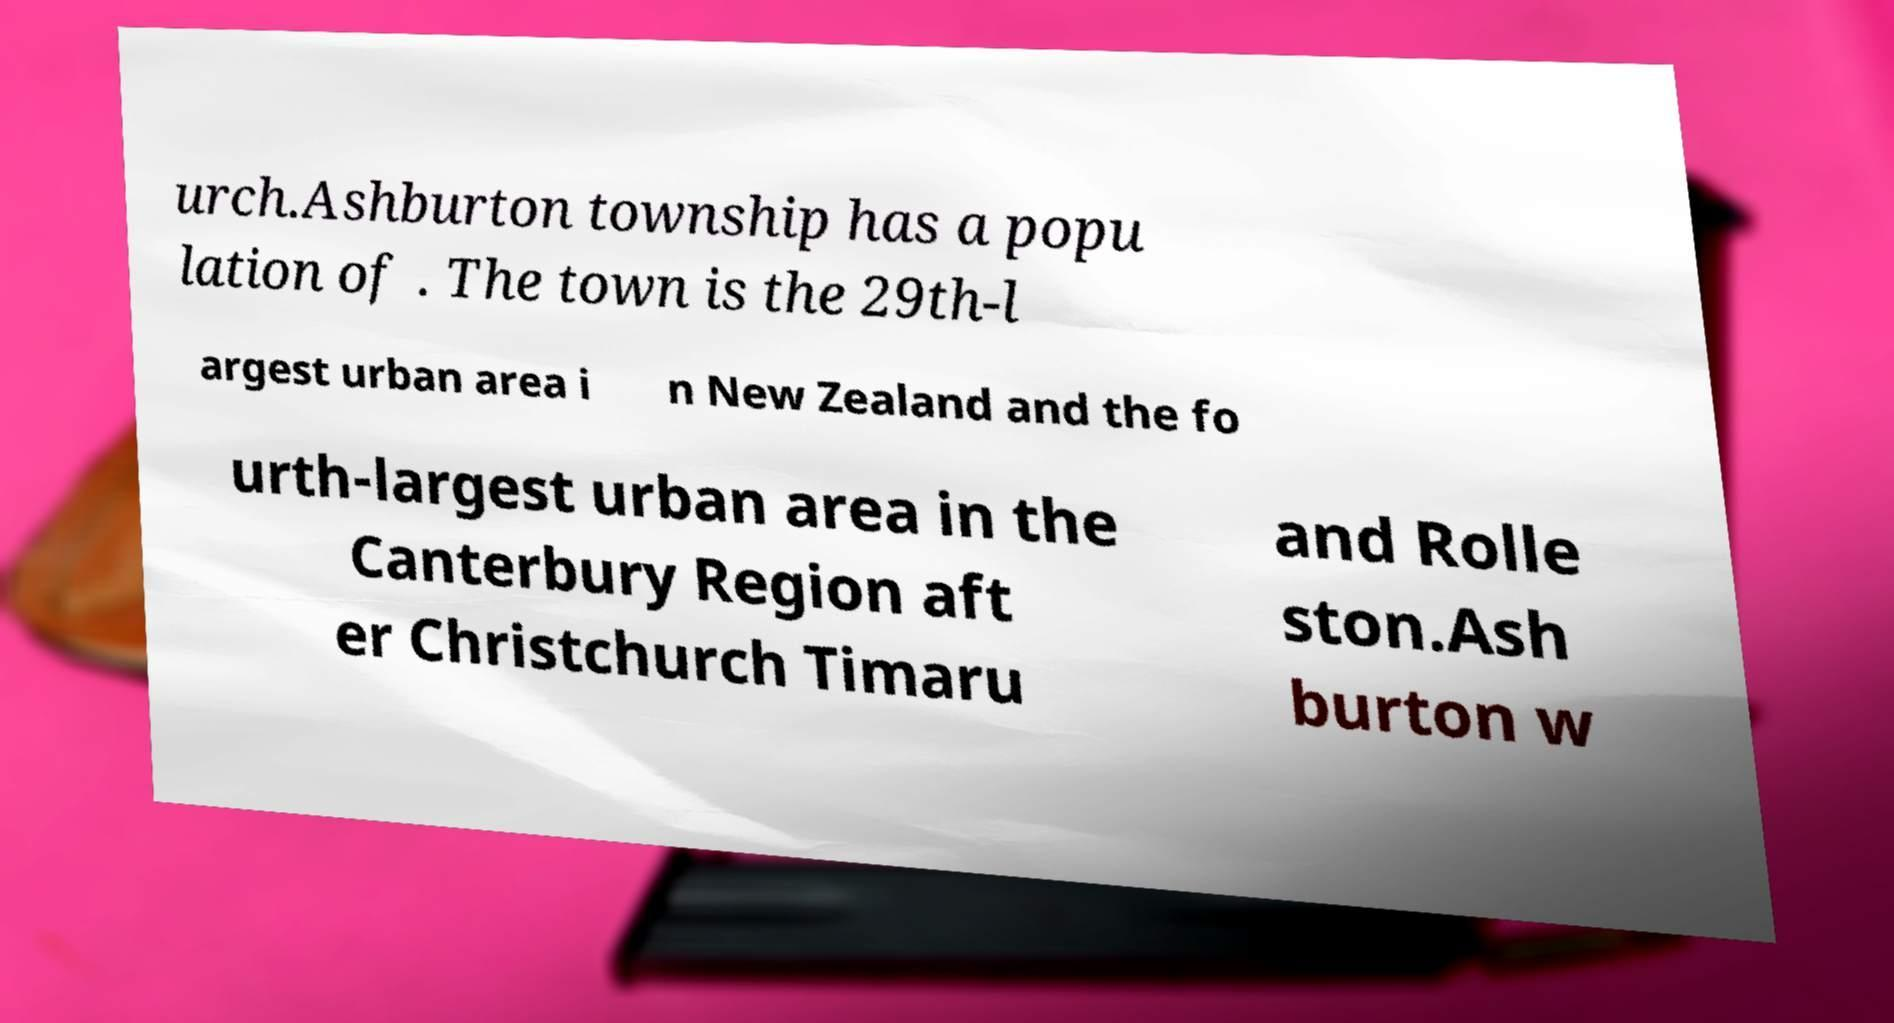For documentation purposes, I need the text within this image transcribed. Could you provide that? urch.Ashburton township has a popu lation of . The town is the 29th-l argest urban area i n New Zealand and the fo urth-largest urban area in the Canterbury Region aft er Christchurch Timaru and Rolle ston.Ash burton w 